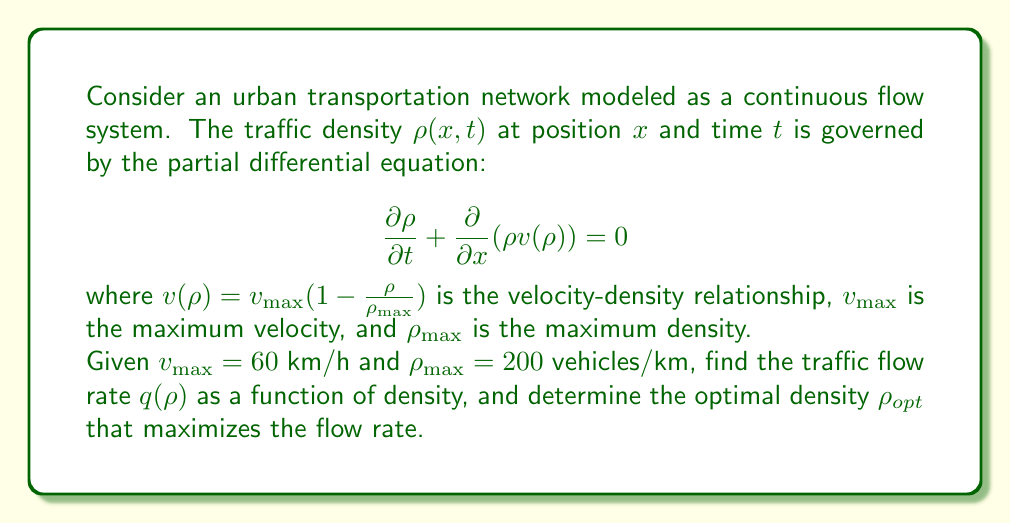Can you answer this question? To solve this problem, we'll follow these steps:

1) First, we need to understand the relationship between flow rate $q$, density $\rho$, and velocity $v$:

   $q = \rho v$

2) We're given the velocity-density relationship:

   $v(\rho) = v_{\max}(1 - \frac{\rho}{\rho_{\max}})$

3) Substituting the given values:

   $v(\rho) = 60(1 - \frac{\rho}{200})$

4) Now, we can express the flow rate $q$ as a function of density $\rho$:

   $q(\rho) = \rho v(\rho) = \rho \cdot 60(1 - \frac{\rho}{200})$

5) Simplifying:

   $q(\rho) = 60\rho - \frac{60\rho^2}{200} = 60\rho - 0.3\rho^2$

6) To find the optimal density that maximizes the flow rate, we need to find the maximum of this function. We can do this by differentiating $q(\rho)$ with respect to $\rho$ and setting it to zero:

   $\frac{dq}{d\rho} = 60 - 0.6\rho$

7) Setting this equal to zero:

   $60 - 0.6\rho = 0$
   $0.6\rho = 60$
   $\rho = 100$

8) To confirm this is a maximum, we can check the second derivative:

   $\frac{d^2q}{d\rho^2} = -0.6 < 0$

   Since this is negative, we confirm that $\rho = 100$ gives a maximum.

9) Therefore, the optimal density $\rho_{opt} = 100$ vehicles/km.

10) We can find the maximum flow rate by substituting this back into our flow rate function:

    $q_{max} = q(100) = 60(100) - 0.3(100)^2 = 6000 - 3000 = 3000$ vehicles/hour
Answer: The traffic flow rate as a function of density is:

$q(\rho) = 60\rho - 0.3\rho^2$ vehicles/hour

The optimal density that maximizes the flow rate is:

$\rho_{opt} = 100$ vehicles/km

The maximum flow rate is:

$q_{max} = 3000$ vehicles/hour 